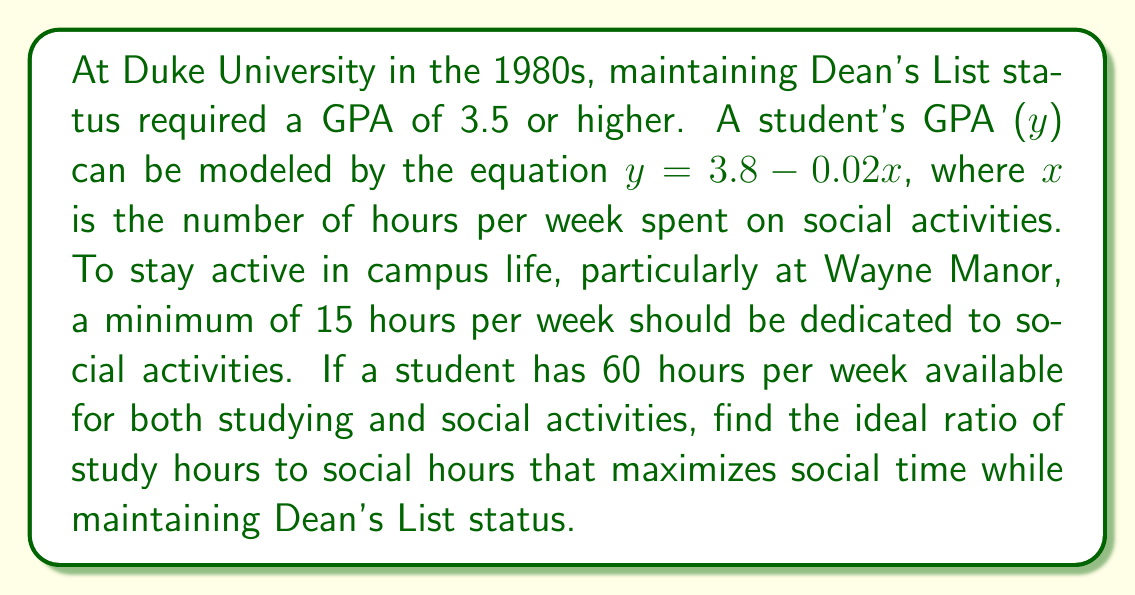Provide a solution to this math problem. Let's approach this step-by-step:

1) First, we need to find the maximum number of social hours ($x$) that still allows for Dean's List status:

   $3.5 = 3.8 - 0.02x$
   $-0.3 = -0.02x$
   $x = 15$

   This coincidentally matches the minimum requirement for active campus life.

2) Now, we know that social hours should be 15, and the total available time is 60 hours.

   Study hours = 60 - 15 = 45

3) To express this as a ratio, we need to simplify 45:15

   45:15 = 3:1

4) This means for every 3 hours of study, there should be 1 hour of social activity.

5) To verify:
   45 hours study + 15 hours social = 60 hours total
   $3.8 - 0.02(15) = 3.5$ GPA, meeting the Dean's List requirement
Answer: 3:1 